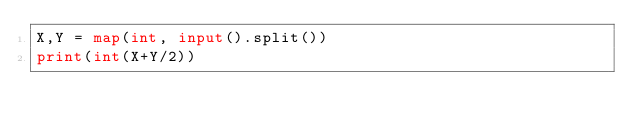Convert code to text. <code><loc_0><loc_0><loc_500><loc_500><_Python_>X,Y = map(int, input().split())
print(int(X+Y/2))</code> 